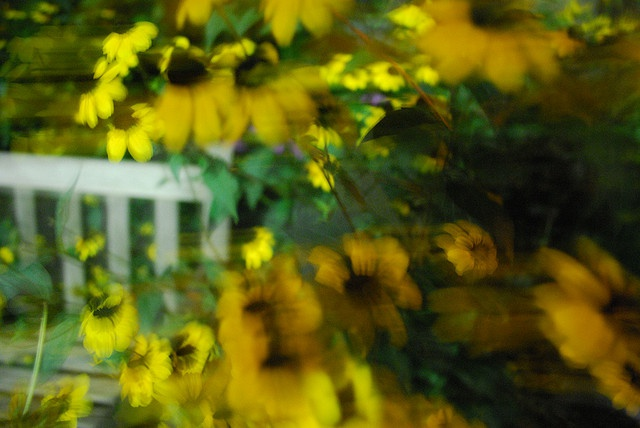Describe the objects in this image and their specific colors. I can see a bench in black, darkgray, green, beige, and olive tones in this image. 